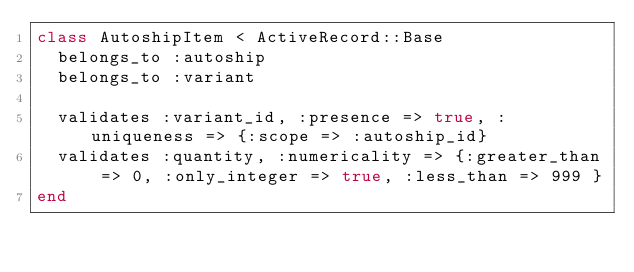Convert code to text. <code><loc_0><loc_0><loc_500><loc_500><_Ruby_>class AutoshipItem < ActiveRecord::Base
  belongs_to :autoship
  belongs_to :variant

  validates :variant_id, :presence => true, :uniqueness => {:scope => :autoship_id}
  validates :quantity, :numericality => {:greater_than => 0, :only_integer => true, :less_than => 999 }
end
</code> 